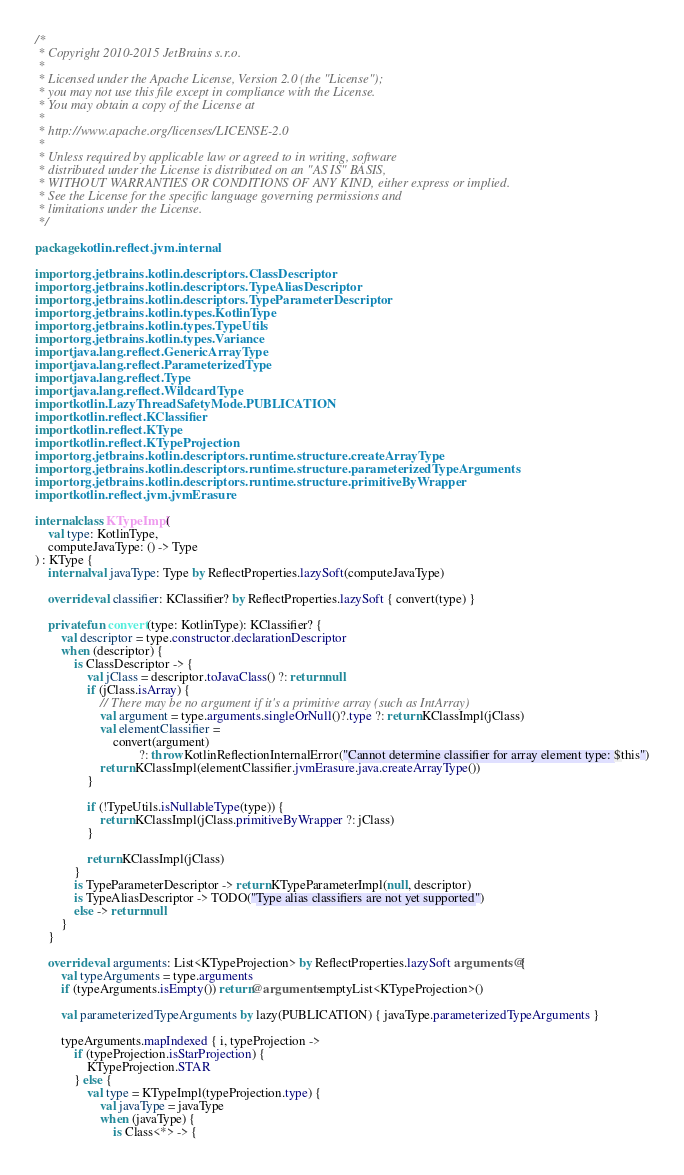<code> <loc_0><loc_0><loc_500><loc_500><_Kotlin_>/*
 * Copyright 2010-2015 JetBrains s.r.o.
 *
 * Licensed under the Apache License, Version 2.0 (the "License");
 * you may not use this file except in compliance with the License.
 * You may obtain a copy of the License at
 *
 * http://www.apache.org/licenses/LICENSE-2.0
 *
 * Unless required by applicable law or agreed to in writing, software
 * distributed under the License is distributed on an "AS IS" BASIS,
 * WITHOUT WARRANTIES OR CONDITIONS OF ANY KIND, either express or implied.
 * See the License for the specific language governing permissions and
 * limitations under the License.
 */

package kotlin.reflect.jvm.internal

import org.jetbrains.kotlin.descriptors.ClassDescriptor
import org.jetbrains.kotlin.descriptors.TypeAliasDescriptor
import org.jetbrains.kotlin.descriptors.TypeParameterDescriptor
import org.jetbrains.kotlin.types.KotlinType
import org.jetbrains.kotlin.types.TypeUtils
import org.jetbrains.kotlin.types.Variance
import java.lang.reflect.GenericArrayType
import java.lang.reflect.ParameterizedType
import java.lang.reflect.Type
import java.lang.reflect.WildcardType
import kotlin.LazyThreadSafetyMode.PUBLICATION
import kotlin.reflect.KClassifier
import kotlin.reflect.KType
import kotlin.reflect.KTypeProjection
import org.jetbrains.kotlin.descriptors.runtime.structure.createArrayType
import org.jetbrains.kotlin.descriptors.runtime.structure.parameterizedTypeArguments
import org.jetbrains.kotlin.descriptors.runtime.structure.primitiveByWrapper
import kotlin.reflect.jvm.jvmErasure

internal class KTypeImpl(
    val type: KotlinType,
    computeJavaType: () -> Type
) : KType {
    internal val javaType: Type by ReflectProperties.lazySoft(computeJavaType)

    override val classifier: KClassifier? by ReflectProperties.lazySoft { convert(type) }

    private fun convert(type: KotlinType): KClassifier? {
        val descriptor = type.constructor.declarationDescriptor
        when (descriptor) {
            is ClassDescriptor -> {
                val jClass = descriptor.toJavaClass() ?: return null
                if (jClass.isArray) {
                    // There may be no argument if it's a primitive array (such as IntArray)
                    val argument = type.arguments.singleOrNull()?.type ?: return KClassImpl(jClass)
                    val elementClassifier =
                        convert(argument)
                                ?: throw KotlinReflectionInternalError("Cannot determine classifier for array element type: $this")
                    return KClassImpl(elementClassifier.jvmErasure.java.createArrayType())
                }

                if (!TypeUtils.isNullableType(type)) {
                    return KClassImpl(jClass.primitiveByWrapper ?: jClass)
                }

                return KClassImpl(jClass)
            }
            is TypeParameterDescriptor -> return KTypeParameterImpl(null, descriptor)
            is TypeAliasDescriptor -> TODO("Type alias classifiers are not yet supported")
            else -> return null
        }
    }

    override val arguments: List<KTypeProjection> by ReflectProperties.lazySoft arguments@{
        val typeArguments = type.arguments
        if (typeArguments.isEmpty()) return@arguments emptyList<KTypeProjection>()

        val parameterizedTypeArguments by lazy(PUBLICATION) { javaType.parameterizedTypeArguments }

        typeArguments.mapIndexed { i, typeProjection ->
            if (typeProjection.isStarProjection) {
                KTypeProjection.STAR
            } else {
                val type = KTypeImpl(typeProjection.type) {
                    val javaType = javaType
                    when (javaType) {
                        is Class<*> -> {</code> 